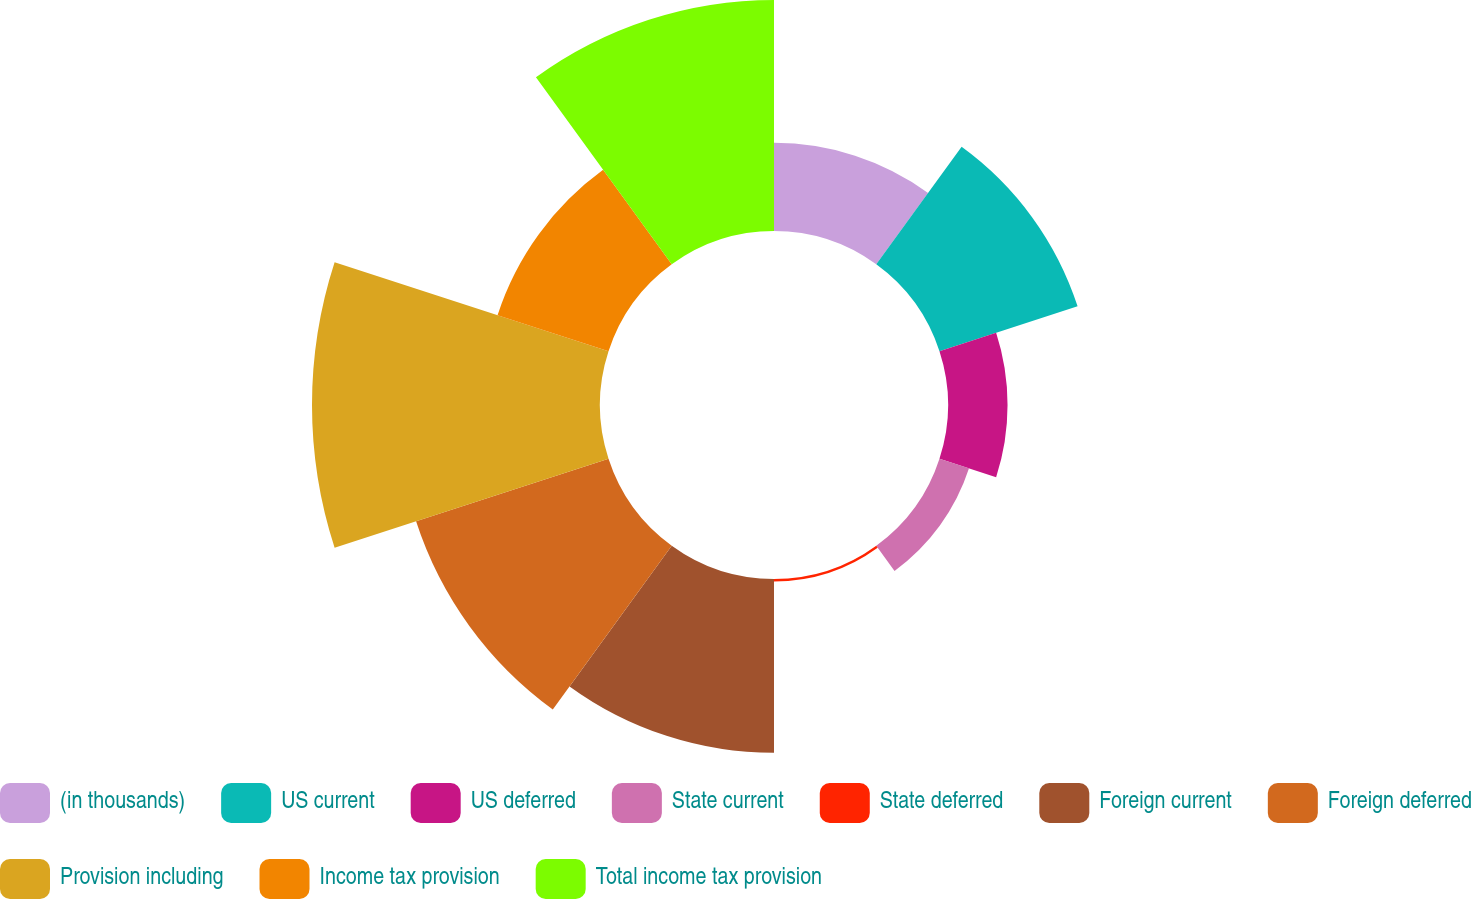Convert chart to OTSL. <chart><loc_0><loc_0><loc_500><loc_500><pie_chart><fcel>(in thousands)<fcel>US current<fcel>US deferred<fcel>State current<fcel>State deferred<fcel>Foreign current<fcel>Foreign deferred<fcel>Provision including<fcel>Income tax provision<fcel>Total income tax provision<nl><fcel>6.59%<fcel>10.85%<fcel>4.45%<fcel>2.32%<fcel>0.18%<fcel>12.99%<fcel>15.12%<fcel>21.52%<fcel>8.72%<fcel>17.26%<nl></chart> 